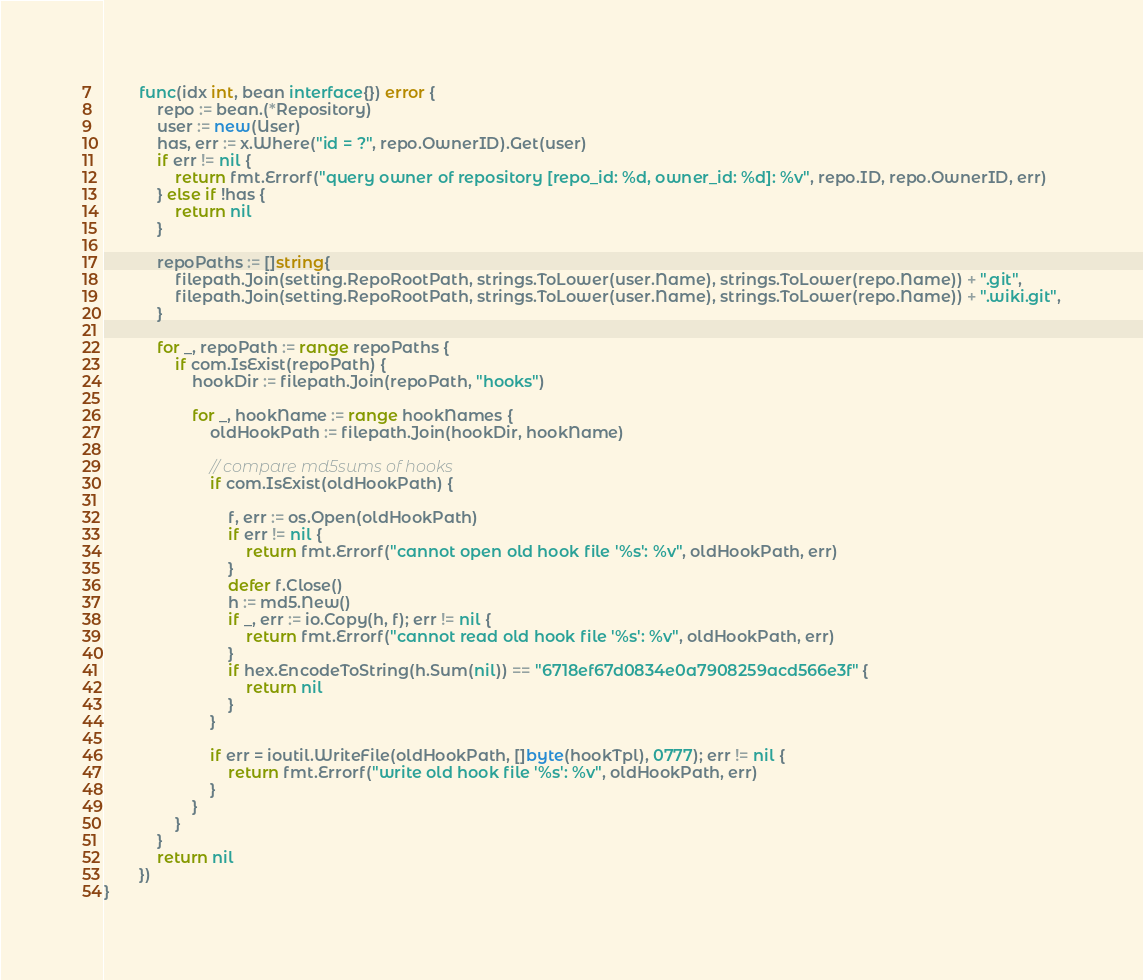Convert code to text. <code><loc_0><loc_0><loc_500><loc_500><_Go_>		func(idx int, bean interface{}) error {
			repo := bean.(*Repository)
			user := new(User)
			has, err := x.Where("id = ?", repo.OwnerID).Get(user)
			if err != nil {
				return fmt.Errorf("query owner of repository [repo_id: %d, owner_id: %d]: %v", repo.ID, repo.OwnerID, err)
			} else if !has {
				return nil
			}

			repoPaths := []string{
				filepath.Join(setting.RepoRootPath, strings.ToLower(user.Name), strings.ToLower(repo.Name)) + ".git",
				filepath.Join(setting.RepoRootPath, strings.ToLower(user.Name), strings.ToLower(repo.Name)) + ".wiki.git",
			}

			for _, repoPath := range repoPaths {
				if com.IsExist(repoPath) {
					hookDir := filepath.Join(repoPath, "hooks")

					for _, hookName := range hookNames {
						oldHookPath := filepath.Join(hookDir, hookName)

						// compare md5sums of hooks
						if com.IsExist(oldHookPath) {

							f, err := os.Open(oldHookPath)
							if err != nil {
								return fmt.Errorf("cannot open old hook file '%s': %v", oldHookPath, err)
							}
							defer f.Close()
							h := md5.New()
							if _, err := io.Copy(h, f); err != nil {
								return fmt.Errorf("cannot read old hook file '%s': %v", oldHookPath, err)
							}
							if hex.EncodeToString(h.Sum(nil)) == "6718ef67d0834e0a7908259acd566e3f" {
								return nil
							}
						}

						if err = ioutil.WriteFile(oldHookPath, []byte(hookTpl), 0777); err != nil {
							return fmt.Errorf("write old hook file '%s': %v", oldHookPath, err)
						}
					}
				}
			}
			return nil
		})
}
</code> 